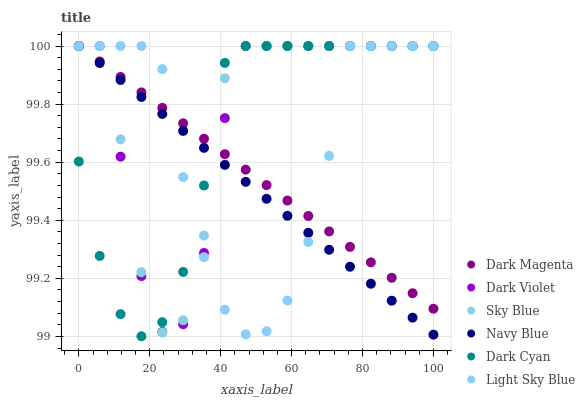Does Navy Blue have the minimum area under the curve?
Answer yes or no. Yes. Does Sky Blue have the maximum area under the curve?
Answer yes or no. Yes. Does Dark Violet have the minimum area under the curve?
Answer yes or no. No. Does Dark Violet have the maximum area under the curve?
Answer yes or no. No. Is Navy Blue the smoothest?
Answer yes or no. Yes. Is Sky Blue the roughest?
Answer yes or no. Yes. Is Dark Violet the smoothest?
Answer yes or no. No. Is Dark Violet the roughest?
Answer yes or no. No. Does Dark Cyan have the lowest value?
Answer yes or no. Yes. Does Navy Blue have the lowest value?
Answer yes or no. No. Does Sky Blue have the highest value?
Answer yes or no. Yes. Does Navy Blue intersect Sky Blue?
Answer yes or no. Yes. Is Navy Blue less than Sky Blue?
Answer yes or no. No. Is Navy Blue greater than Sky Blue?
Answer yes or no. No. 